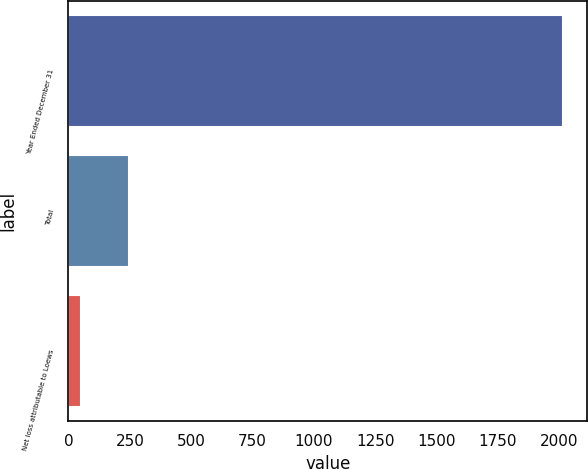<chart> <loc_0><loc_0><loc_500><loc_500><bar_chart><fcel>Year Ended December 31<fcel>Total<fcel>Net loss attributable to Loews<nl><fcel>2014<fcel>248.2<fcel>52<nl></chart> 